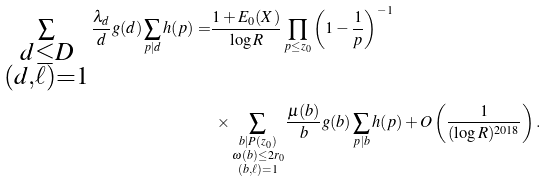Convert formula to latex. <formula><loc_0><loc_0><loc_500><loc_500>\sum _ { \substack { d \leq D \\ ( d , \ell ) = 1 } } \frac { \lambda _ { d } } { d } g ( d ) \sum _ { p | d } h ( p ) = & \frac { 1 + E _ { 0 } ( X ) } { \log R } \prod _ { p \leq z _ { 0 } } \left ( 1 - \frac { 1 } { p } \right ) ^ { - 1 } \\ & \ \times \sum _ { \substack { b | P ( z _ { 0 } ) \\ \omega ( b ) \leq 2 r _ { 0 } \\ ( b , \ell ) = 1 } } \frac { \mu ( b ) } { b } g ( b ) \sum _ { p | b } h ( p ) + O \left ( \frac { 1 } { ( \log R ) ^ { 2 0 1 8 } } \right ) .</formula> 